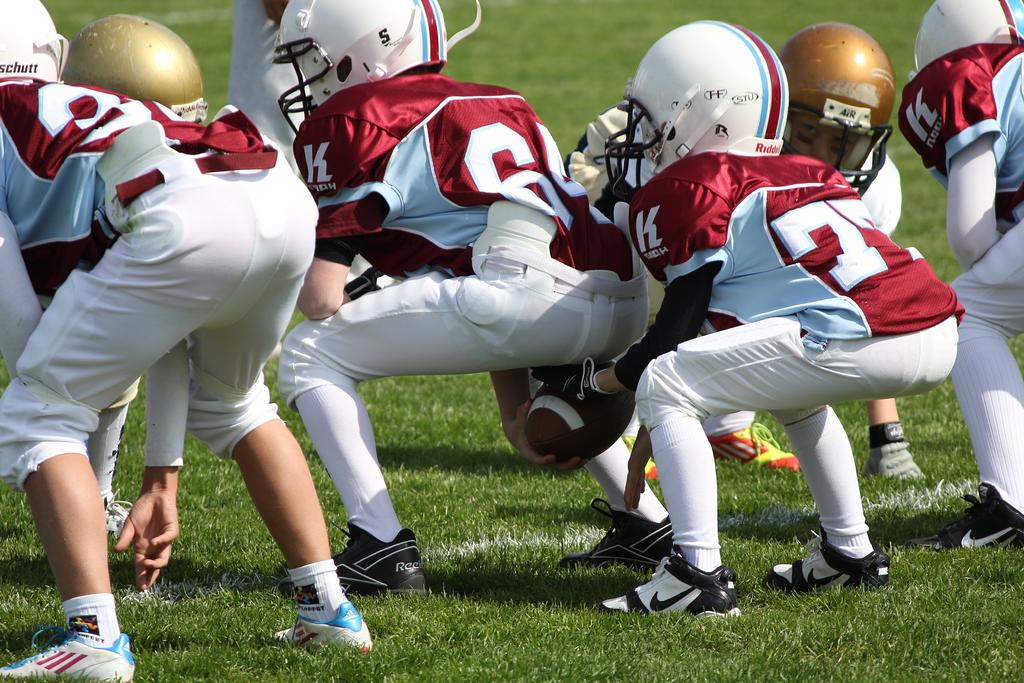Who or what is present in the image? There are people in the image. What are the people wearing on their heads? The people are wearing helmets. Where are the people located in the image? The people are on the ground. What type of rake is being used by the people in the image? There is no rake present in the image; the people are wearing helmets and are on the ground. 